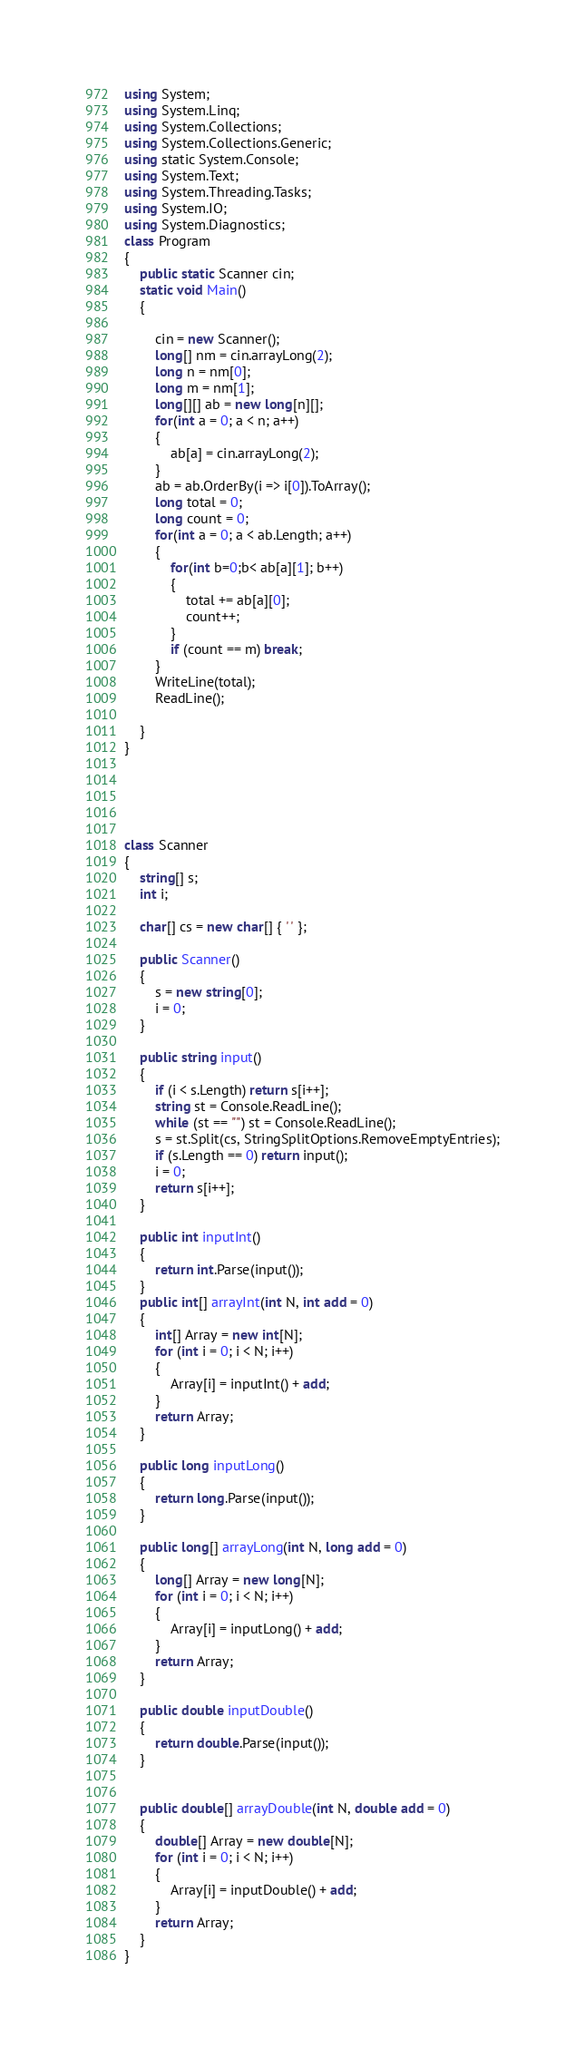<code> <loc_0><loc_0><loc_500><loc_500><_C#_>using System;
using System.Linq;
using System.Collections;
using System.Collections.Generic;
using static System.Console;
using System.Text;
using System.Threading.Tasks;
using System.IO;
using System.Diagnostics;
class Program
{
    public static Scanner cin;
    static void Main()
    {
        
        cin = new Scanner();
        long[] nm = cin.arrayLong(2);
        long n = nm[0];
        long m = nm[1];
        long[][] ab = new long[n][];
        for(int a = 0; a < n; a++)
        {
            ab[a] = cin.arrayLong(2);
        }
        ab = ab.OrderBy(i => i[0]).ToArray();
        long total = 0;
        long count = 0;
        for(int a = 0; a < ab.Length; a++)
        {
            for(int b=0;b< ab[a][1]; b++)
            {
                total += ab[a][0];
                count++;
            }
            if (count == m) break;
        }
        WriteLine(total);
        ReadLine();

    }
}





class Scanner
{
    string[] s;
    int i;

    char[] cs = new char[] { ' ' };

    public Scanner()
    {
        s = new string[0];
        i = 0;
    }

    public string input()
    {
        if (i < s.Length) return s[i++];
        string st = Console.ReadLine();
        while (st == "") st = Console.ReadLine();
        s = st.Split(cs, StringSplitOptions.RemoveEmptyEntries);
        if (s.Length == 0) return input();
        i = 0;
        return s[i++];
    }

    public int inputInt()
    {
        return int.Parse(input());
    }
    public int[] arrayInt(int N, int add = 0)
    {
        int[] Array = new int[N];
        for (int i = 0; i < N; i++)
        {
            Array[i] = inputInt() + add;
        }
        return Array;
    }

    public long inputLong()
    {
        return long.Parse(input());
    }

    public long[] arrayLong(int N, long add = 0)
    {
        long[] Array = new long[N];
        for (int i = 0; i < N; i++)
        {
            Array[i] = inputLong() + add;
        }
        return Array;
    }

    public double inputDouble()
    {
        return double.Parse(input());
    }


    public double[] arrayDouble(int N, double add = 0)
    {
        double[] Array = new double[N];
        for (int i = 0; i < N; i++)
        {
            Array[i] = inputDouble() + add;
        }
        return Array;
    }
}</code> 